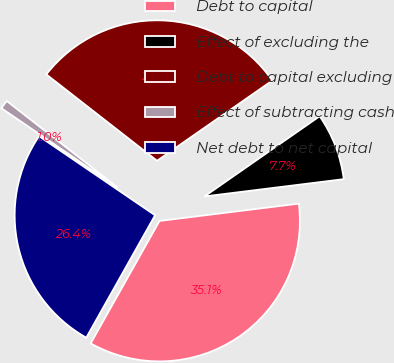Convert chart. <chart><loc_0><loc_0><loc_500><loc_500><pie_chart><fcel>Debt to capital<fcel>Effect of excluding the<fcel>Debt to capital excluding<fcel>Effect of subtracting cash<fcel>Net debt to net capital<nl><fcel>35.11%<fcel>7.71%<fcel>29.78%<fcel>1.02%<fcel>26.37%<nl></chart> 